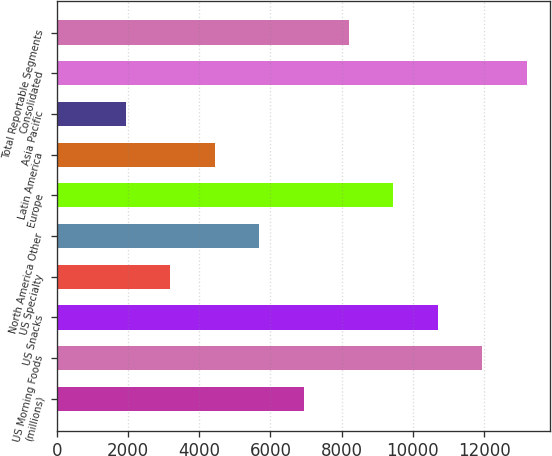<chart> <loc_0><loc_0><loc_500><loc_500><bar_chart><fcel>(millions)<fcel>US Morning Foods<fcel>US Snacks<fcel>US Specialty<fcel>North America Other<fcel>Europe<fcel>Latin America<fcel>Asia Pacific<fcel>Consolidated<fcel>Total Reportable Segments<nl><fcel>6941<fcel>11946.6<fcel>10695.2<fcel>3186.8<fcel>5689.6<fcel>9443.8<fcel>4438.2<fcel>1935.4<fcel>13198<fcel>8192.4<nl></chart> 